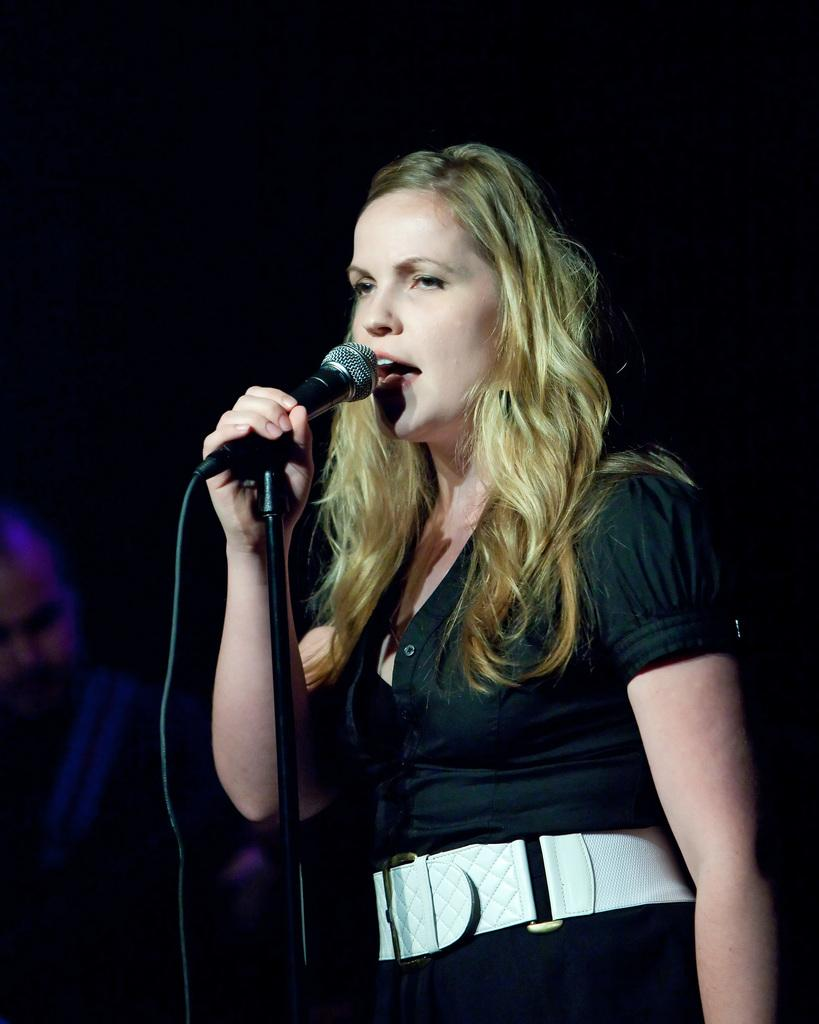What is the main subject of the image? The main subject of the image is a woman. What is the woman doing in the image? The woman is standing and singing in the image. What object is the woman holding in the image? The woman is holding a microphone in the image. What can be observed about the background of the image? The background of the image is dark. What type of lock can be seen on the microphone in the image? There is no lock present on the microphone in the image. What caption is written on the woman's shirt in the image? There is no caption visible on the woman's shirt in the image. 